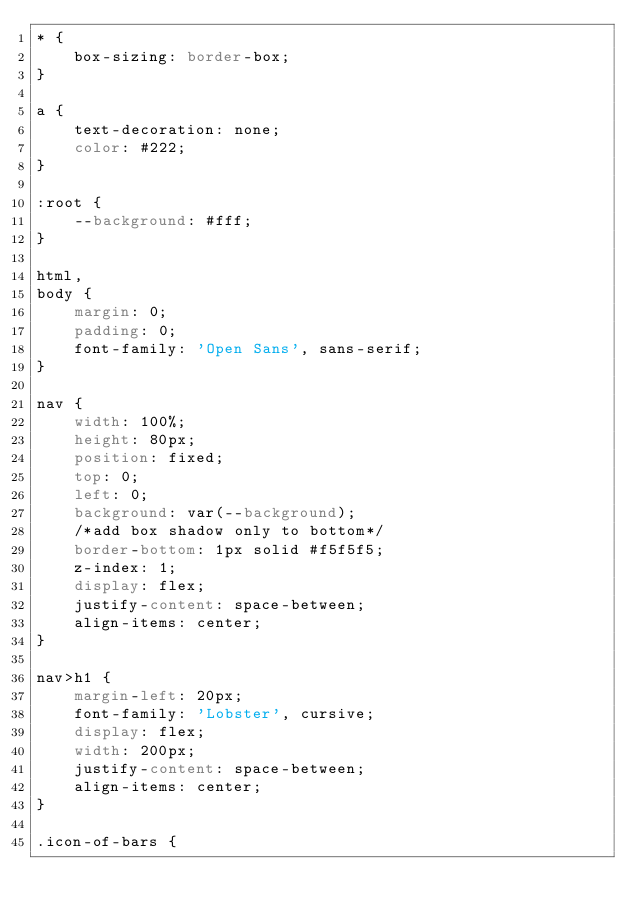<code> <loc_0><loc_0><loc_500><loc_500><_CSS_>* {
    box-sizing: border-box;
}

a {
    text-decoration: none;
    color: #222;
}

:root {
    --background: #fff;
}

html,
body {
    margin: 0;
    padding: 0;
    font-family: 'Open Sans', sans-serif;
}

nav {
    width: 100%;
    height: 80px;
    position: fixed;
    top: 0;
    left: 0;
    background: var(--background);
    /*add box shadow only to bottom*/
    border-bottom: 1px solid #f5f5f5;
    z-index: 1;
    display: flex;
    justify-content: space-between;
    align-items: center;
}

nav>h1 {
    margin-left: 20px;
    font-family: 'Lobster', cursive;
    display: flex;
    width: 200px;
    justify-content: space-between;
    align-items: center;
}

.icon-of-bars {</code> 